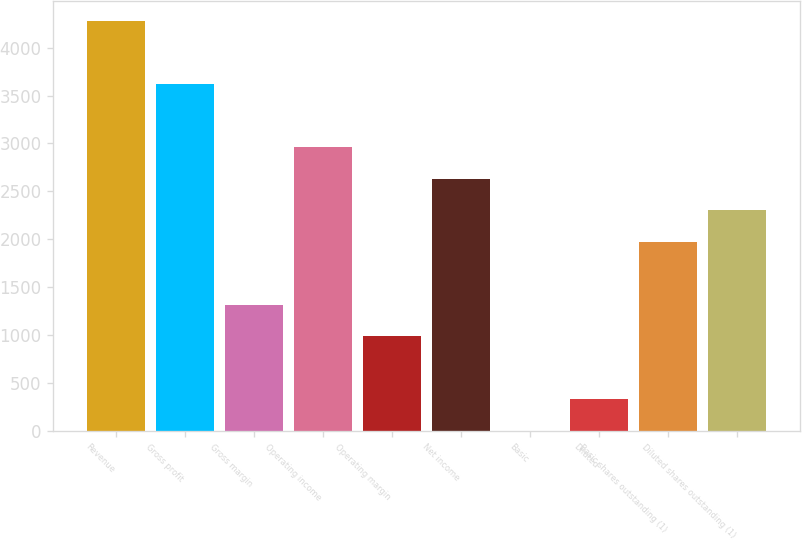Convert chart to OTSL. <chart><loc_0><loc_0><loc_500><loc_500><bar_chart><fcel>Revenue<fcel>Gross profit<fcel>Gross margin<fcel>Operating income<fcel>Operating margin<fcel>Net income<fcel>Basic<fcel>Diluted<fcel>Basic shares outstanding (1)<fcel>Diluted shares outstanding (1)<nl><fcel>4277.96<fcel>3620<fcel>1317.14<fcel>2962.04<fcel>988.16<fcel>2633.06<fcel>1.22<fcel>330.2<fcel>1975.1<fcel>2304.08<nl></chart> 